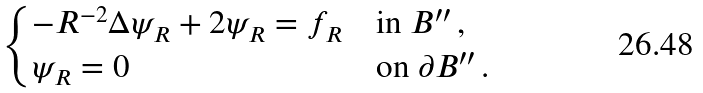<formula> <loc_0><loc_0><loc_500><loc_500>\begin{cases} - R ^ { - 2 } \Delta \psi _ { R } + 2 \psi _ { R } = f _ { R } & \text {in $B^{\prime\prime}$} \, , \\ \psi _ { R } = 0 & \text {on $\partial B^{\prime\prime}$} \, . \end{cases}</formula> 